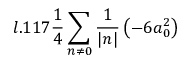<formula> <loc_0><loc_0><loc_500><loc_500>l . 1 1 7 \frac { 1 } { 4 } \sum _ { n \neq 0 } \frac { 1 } { | n | } \left ( - 6 a _ { 0 } ^ { 2 } \right )</formula> 